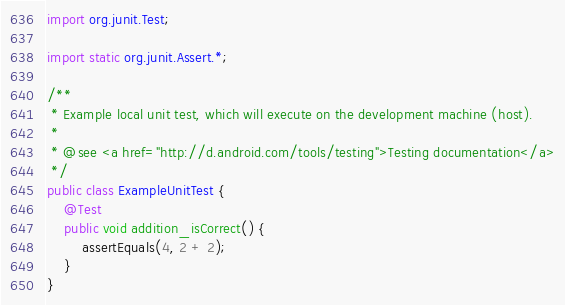<code> <loc_0><loc_0><loc_500><loc_500><_Java_>
import org.junit.Test;

import static org.junit.Assert.*;

/**
 * Example local unit test, which will execute on the development machine (host).
 *
 * @see <a href="http://d.android.com/tools/testing">Testing documentation</a>
 */
public class ExampleUnitTest {
    @Test
    public void addition_isCorrect() {
        assertEquals(4, 2 + 2);
    }
}</code> 